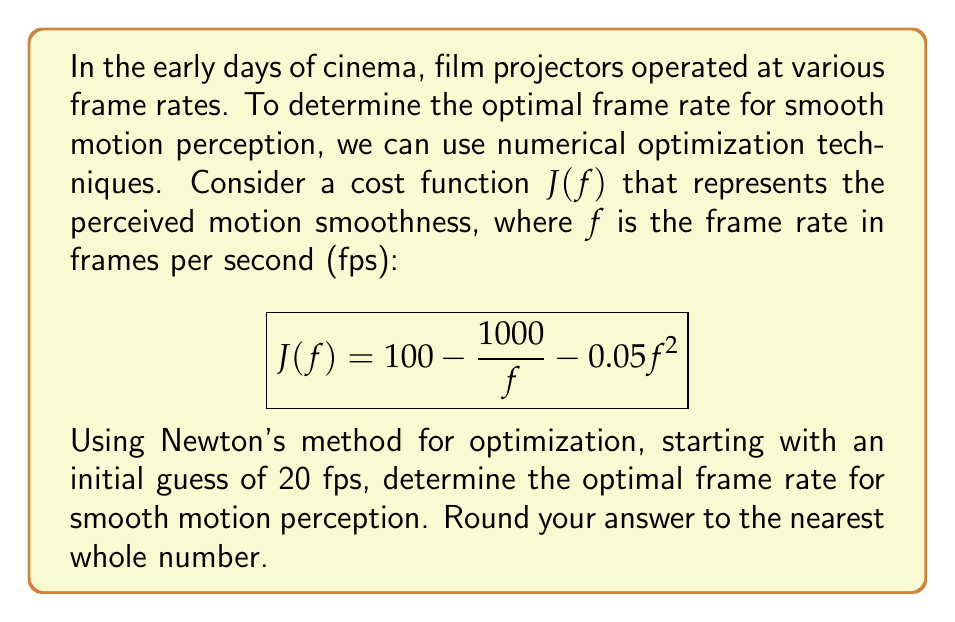Can you answer this question? To solve this problem using Newton's method, we follow these steps:

1) The Newton's method formula for optimization is:

   $$f_{n+1} = f_n - \frac{J'(f_n)}{J''(f_n)}$$

2) We need to find $J'(f)$ and $J''(f)$:
   
   $$J'(f) = \frac{1000}{f^2} - 0.1f$$
   $$J''(f) = -\frac{2000}{f^3} - 0.1$$

3) Starting with $f_0 = 20$, we iterate:

   $f_1 = 20 - \frac{J'(20)}{J''(20)}$
   
   $= 20 - \frac{1000/400 - 0.1(20)}{-2000/8000 - 0.1}$
   
   $= 20 - \frac{0.5}{-0.35} \approx 21.43$

4) For $f_1 = 21.43$:

   $f_2 = 21.43 - \frac{1000/459.65 - 0.1(21.43)}{-2000/9869.41 - 0.1}$
   
   $\approx 22.72$

5) For $f_2 = 22.72$:

   $f_3 = 22.72 - \frac{1000/516.20 - 0.1(22.72)}{-2000/11733.76 - 0.1}$
   
   $\approx 23.97$

6) For $f_3 = 23.97$:

   $f_4 = 23.97 - \frac{1000/574.56 - 0.1(23.97)}{-2000/13778.38 - 0.1}$
   
   $\approx 24.00$

The method converges at approximately 24 fps.
Answer: 24 fps 